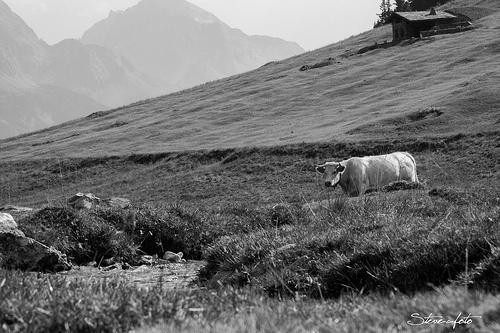How many cows are shown?
Give a very brief answer. 1. 